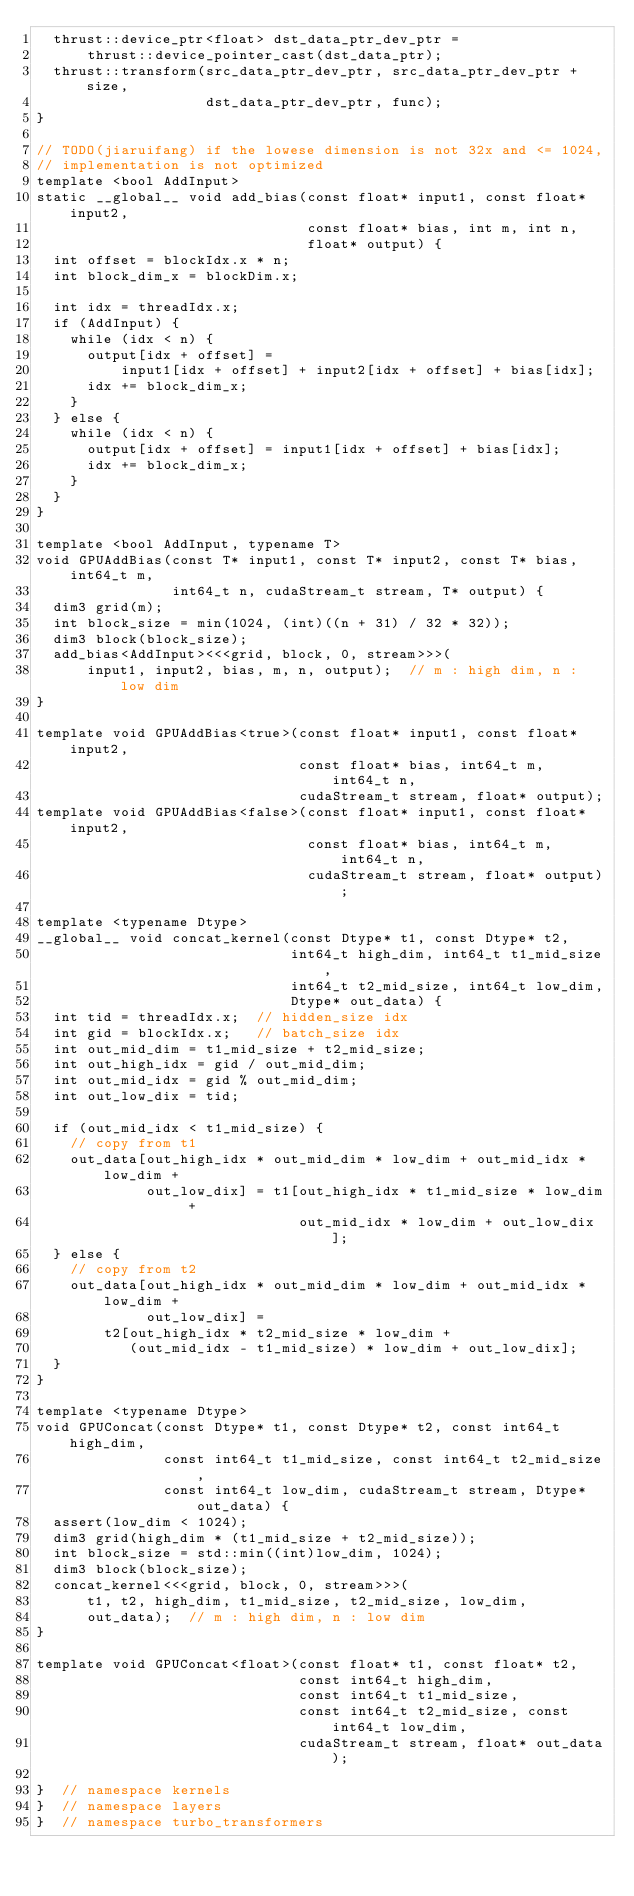Convert code to text. <code><loc_0><loc_0><loc_500><loc_500><_Cuda_>  thrust::device_ptr<float> dst_data_ptr_dev_ptr =
      thrust::device_pointer_cast(dst_data_ptr);
  thrust::transform(src_data_ptr_dev_ptr, src_data_ptr_dev_ptr + size,
                    dst_data_ptr_dev_ptr, func);
}

// TODO(jiaruifang) if the lowese dimension is not 32x and <= 1024,
// implementation is not optimized
template <bool AddInput>
static __global__ void add_bias(const float* input1, const float* input2,
                                const float* bias, int m, int n,
                                float* output) {
  int offset = blockIdx.x * n;
  int block_dim_x = blockDim.x;

  int idx = threadIdx.x;
  if (AddInput) {
    while (idx < n) {
      output[idx + offset] =
          input1[idx + offset] + input2[idx + offset] + bias[idx];
      idx += block_dim_x;
    }
  } else {
    while (idx < n) {
      output[idx + offset] = input1[idx + offset] + bias[idx];
      idx += block_dim_x;
    }
  }
}

template <bool AddInput, typename T>
void GPUAddBias(const T* input1, const T* input2, const T* bias, int64_t m,
                int64_t n, cudaStream_t stream, T* output) {
  dim3 grid(m);
  int block_size = min(1024, (int)((n + 31) / 32 * 32));
  dim3 block(block_size);
  add_bias<AddInput><<<grid, block, 0, stream>>>(
      input1, input2, bias, m, n, output);  // m : high dim, n : low dim
}

template void GPUAddBias<true>(const float* input1, const float* input2,
                               const float* bias, int64_t m, int64_t n,
                               cudaStream_t stream, float* output);
template void GPUAddBias<false>(const float* input1, const float* input2,
                                const float* bias, int64_t m, int64_t n,
                                cudaStream_t stream, float* output);

template <typename Dtype>
__global__ void concat_kernel(const Dtype* t1, const Dtype* t2,
                              int64_t high_dim, int64_t t1_mid_size,
                              int64_t t2_mid_size, int64_t low_dim,
                              Dtype* out_data) {
  int tid = threadIdx.x;  // hidden_size idx
  int gid = blockIdx.x;   // batch_size idx
  int out_mid_dim = t1_mid_size + t2_mid_size;
  int out_high_idx = gid / out_mid_dim;
  int out_mid_idx = gid % out_mid_dim;
  int out_low_dix = tid;

  if (out_mid_idx < t1_mid_size) {
    // copy from t1
    out_data[out_high_idx * out_mid_dim * low_dim + out_mid_idx * low_dim +
             out_low_dix] = t1[out_high_idx * t1_mid_size * low_dim +
                               out_mid_idx * low_dim + out_low_dix];
  } else {
    // copy from t2
    out_data[out_high_idx * out_mid_dim * low_dim + out_mid_idx * low_dim +
             out_low_dix] =
        t2[out_high_idx * t2_mid_size * low_dim +
           (out_mid_idx - t1_mid_size) * low_dim + out_low_dix];
  }
}

template <typename Dtype>
void GPUConcat(const Dtype* t1, const Dtype* t2, const int64_t high_dim,
               const int64_t t1_mid_size, const int64_t t2_mid_size,
               const int64_t low_dim, cudaStream_t stream, Dtype* out_data) {
  assert(low_dim < 1024);
  dim3 grid(high_dim * (t1_mid_size + t2_mid_size));
  int block_size = std::min((int)low_dim, 1024);
  dim3 block(block_size);
  concat_kernel<<<grid, block, 0, stream>>>(
      t1, t2, high_dim, t1_mid_size, t2_mid_size, low_dim,
      out_data);  // m : high dim, n : low dim
}

template void GPUConcat<float>(const float* t1, const float* t2,
                               const int64_t high_dim,
                               const int64_t t1_mid_size,
                               const int64_t t2_mid_size, const int64_t low_dim,
                               cudaStream_t stream, float* out_data);

}  // namespace kernels
}  // namespace layers
}  // namespace turbo_transformers
</code> 